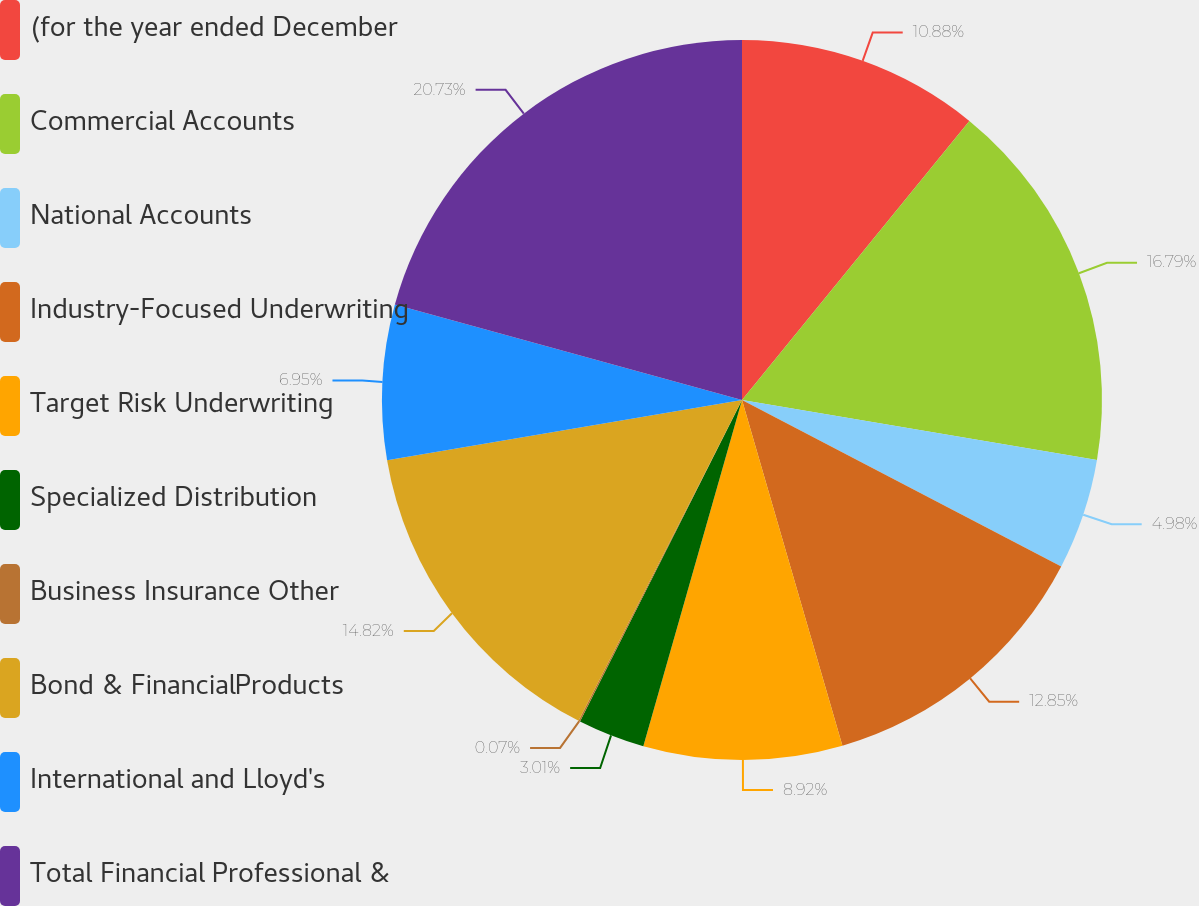Convert chart. <chart><loc_0><loc_0><loc_500><loc_500><pie_chart><fcel>(for the year ended December<fcel>Commercial Accounts<fcel>National Accounts<fcel>Industry-Focused Underwriting<fcel>Target Risk Underwriting<fcel>Specialized Distribution<fcel>Business Insurance Other<fcel>Bond & FinancialProducts<fcel>International and Lloyd's<fcel>Total Financial Professional &<nl><fcel>10.88%<fcel>16.79%<fcel>4.98%<fcel>12.85%<fcel>8.92%<fcel>3.01%<fcel>0.07%<fcel>14.82%<fcel>6.95%<fcel>20.73%<nl></chart> 